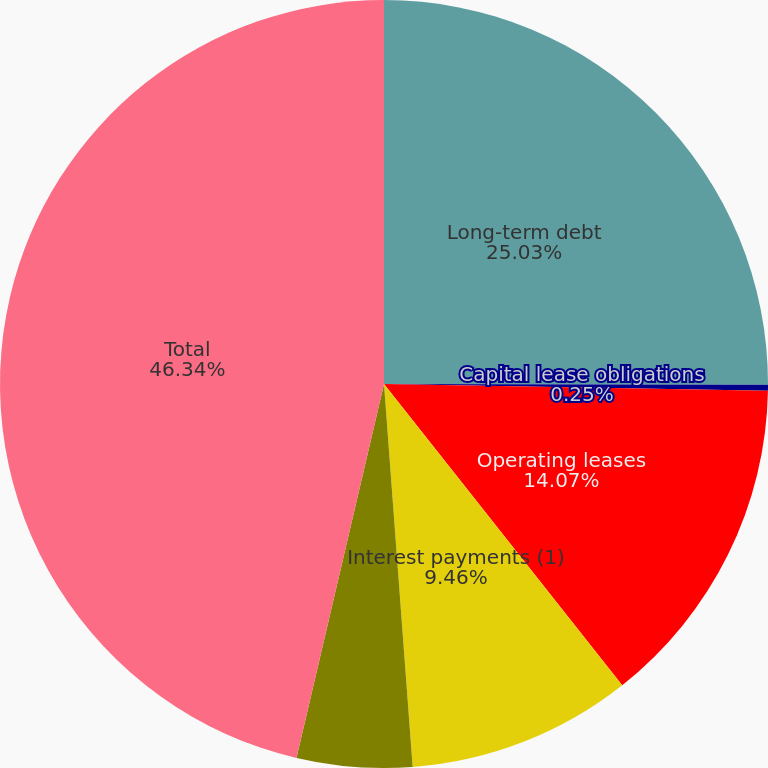<chart> <loc_0><loc_0><loc_500><loc_500><pie_chart><fcel>Long-term debt<fcel>Capital lease obligations<fcel>Operating leases<fcel>Interest payments (1)<fcel>Unconditional purchase<fcel>Total<nl><fcel>25.03%<fcel>0.25%<fcel>14.07%<fcel>9.46%<fcel>4.85%<fcel>46.34%<nl></chart> 